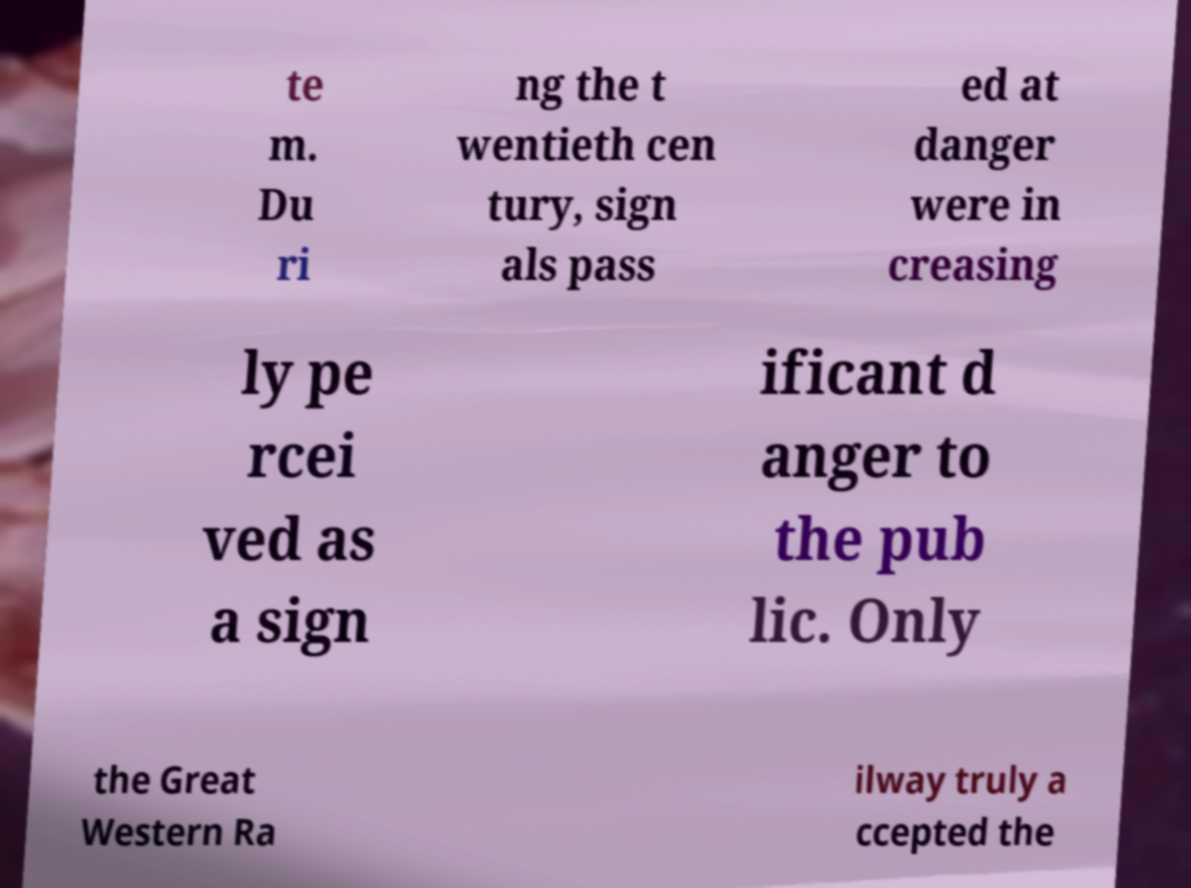I need the written content from this picture converted into text. Can you do that? te m. Du ri ng the t wentieth cen tury, sign als pass ed at danger were in creasing ly pe rcei ved as a sign ificant d anger to the pub lic. Only the Great Western Ra ilway truly a ccepted the 